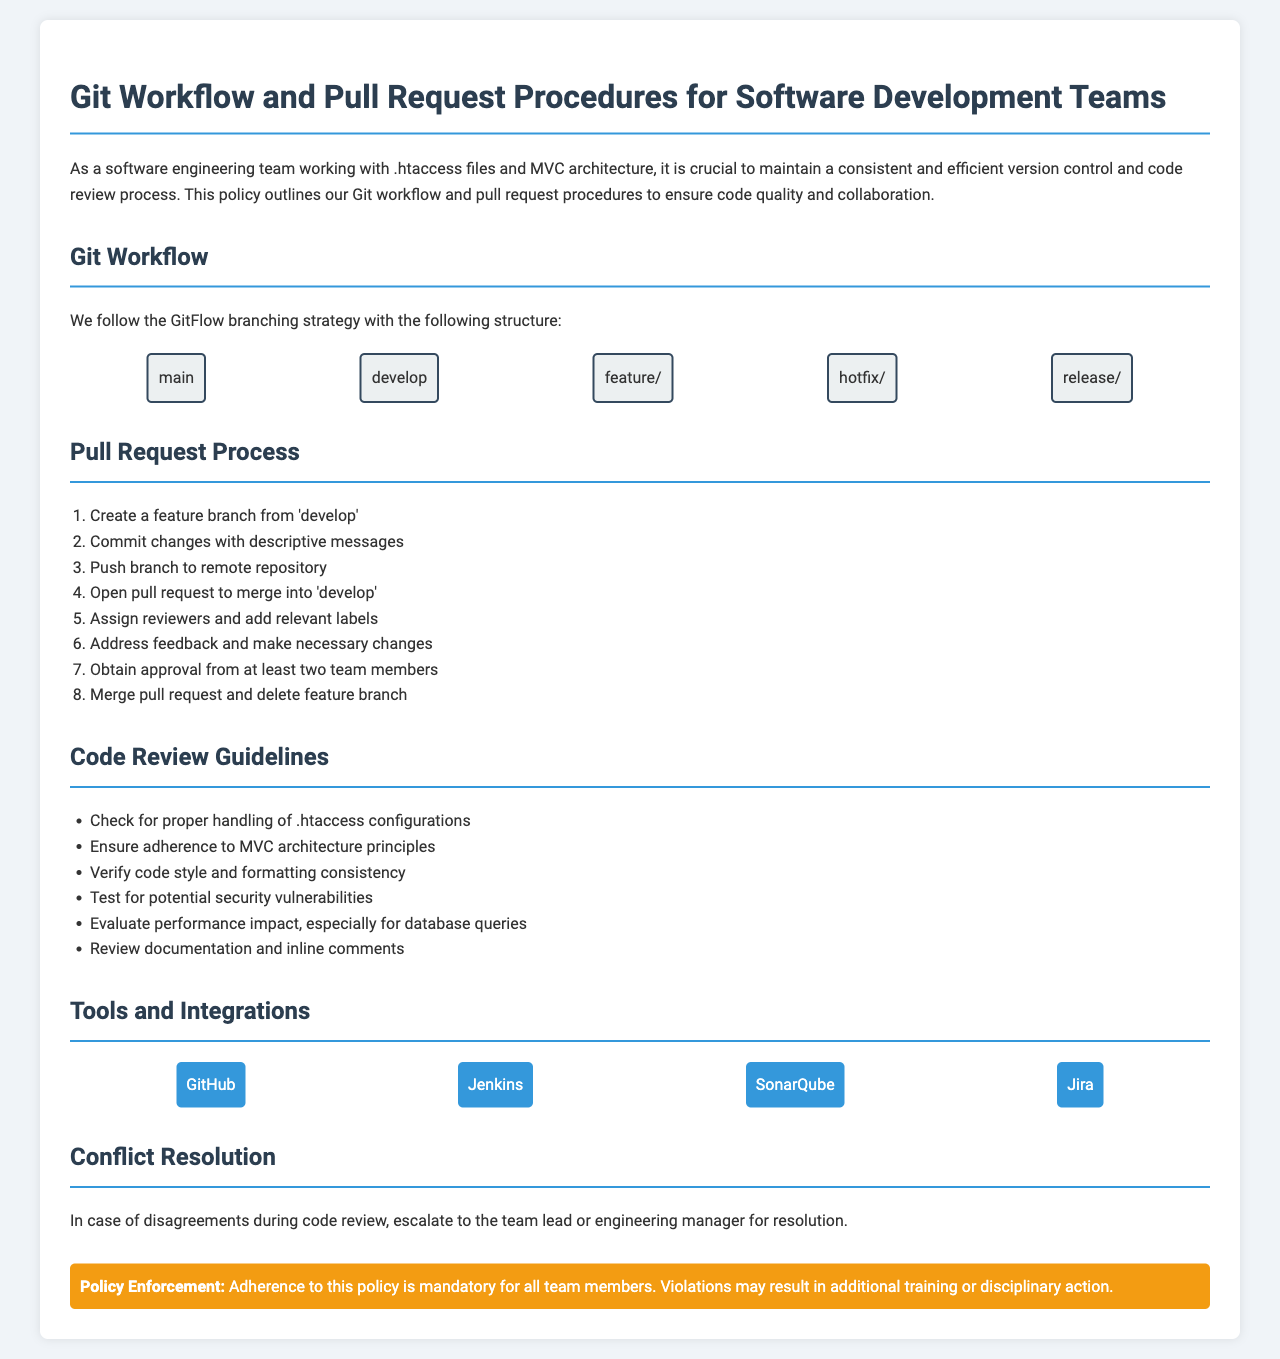what is the primary branching strategy used? The document states that the team follows the GitFlow branching strategy.
Answer: GitFlow how many team members must approve a pull request? According to the document, a pull request requires approval from at least two team members.
Answer: two what should you check for during the code review regarding .htaccess? The document specifies to check for proper handling of .htaccess configurations during the code review.
Answer: proper handling of .htaccess configurations which tool is mentioned for integration with the Git workflow? One of the tools listed for integration in the workflow is GitHub.
Answer: GitHub what is the first step in the pull request process? The document outlines that the first step in the pull request process is to create a feature branch from 'develop'.
Answer: Create a feature branch from 'develop' what action is suggested if there is a disagreement during a code review? In case of disagreements, the document suggests escalating to the team lead or engineering manager for resolution.
Answer: escalate to the team lead or engineering manager what is required before merging a pull request? The document states that you must obtain approval from at least two team members before merging a pull request.
Answer: approval from at least two team members what type of action may occur for policy violations? The document indicates that violations may result in additional training or disciplinary action.
Answer: additional training or disciplinary action 